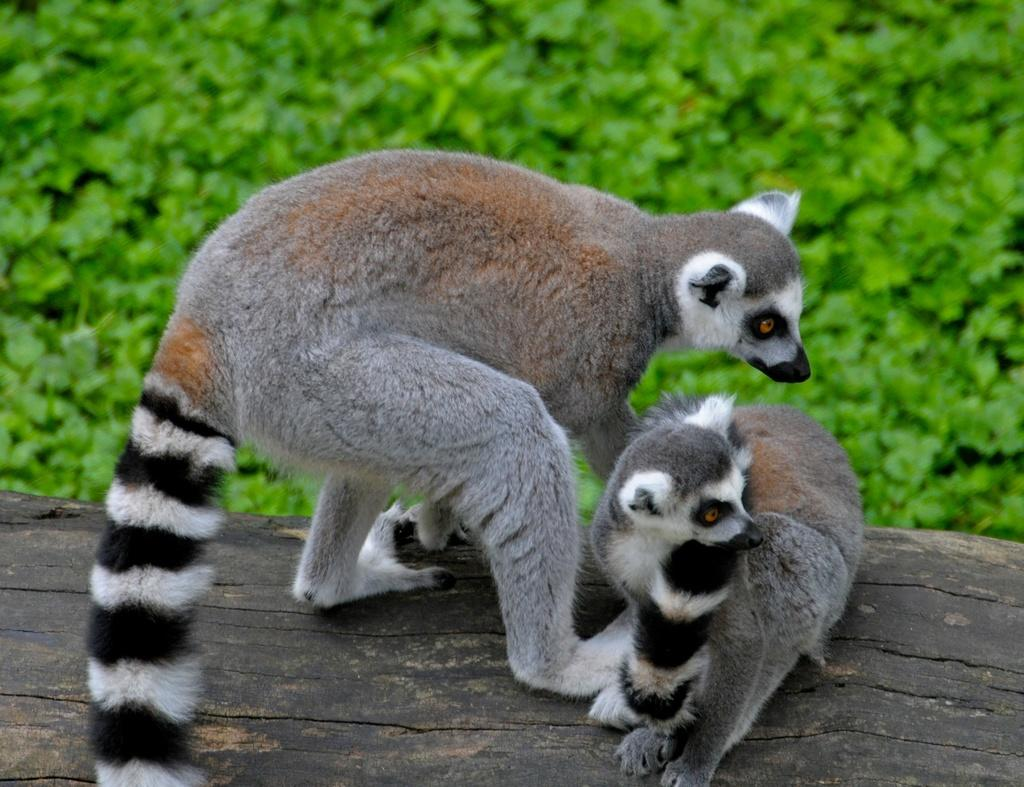What is the main subject of the image? The main subject of the image is animals. Where are the animals located in the image? The animals are on a wooden block in the center of the image. What can be seen in the background of the image? There are plants in the background of the image. What type of error can be seen in the image? There is no error present in the image. Can you tell me how many baskets are visible in the image? There are no baskets present in the image. 